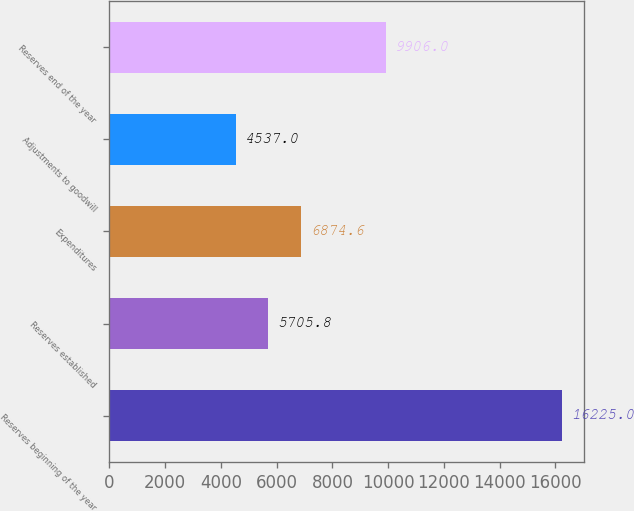<chart> <loc_0><loc_0><loc_500><loc_500><bar_chart><fcel>Reserves beginning of the year<fcel>Reserves established<fcel>Expenditures<fcel>Adjustments to goodwill<fcel>Reserves end of the year<nl><fcel>16225<fcel>5705.8<fcel>6874.6<fcel>4537<fcel>9906<nl></chart> 